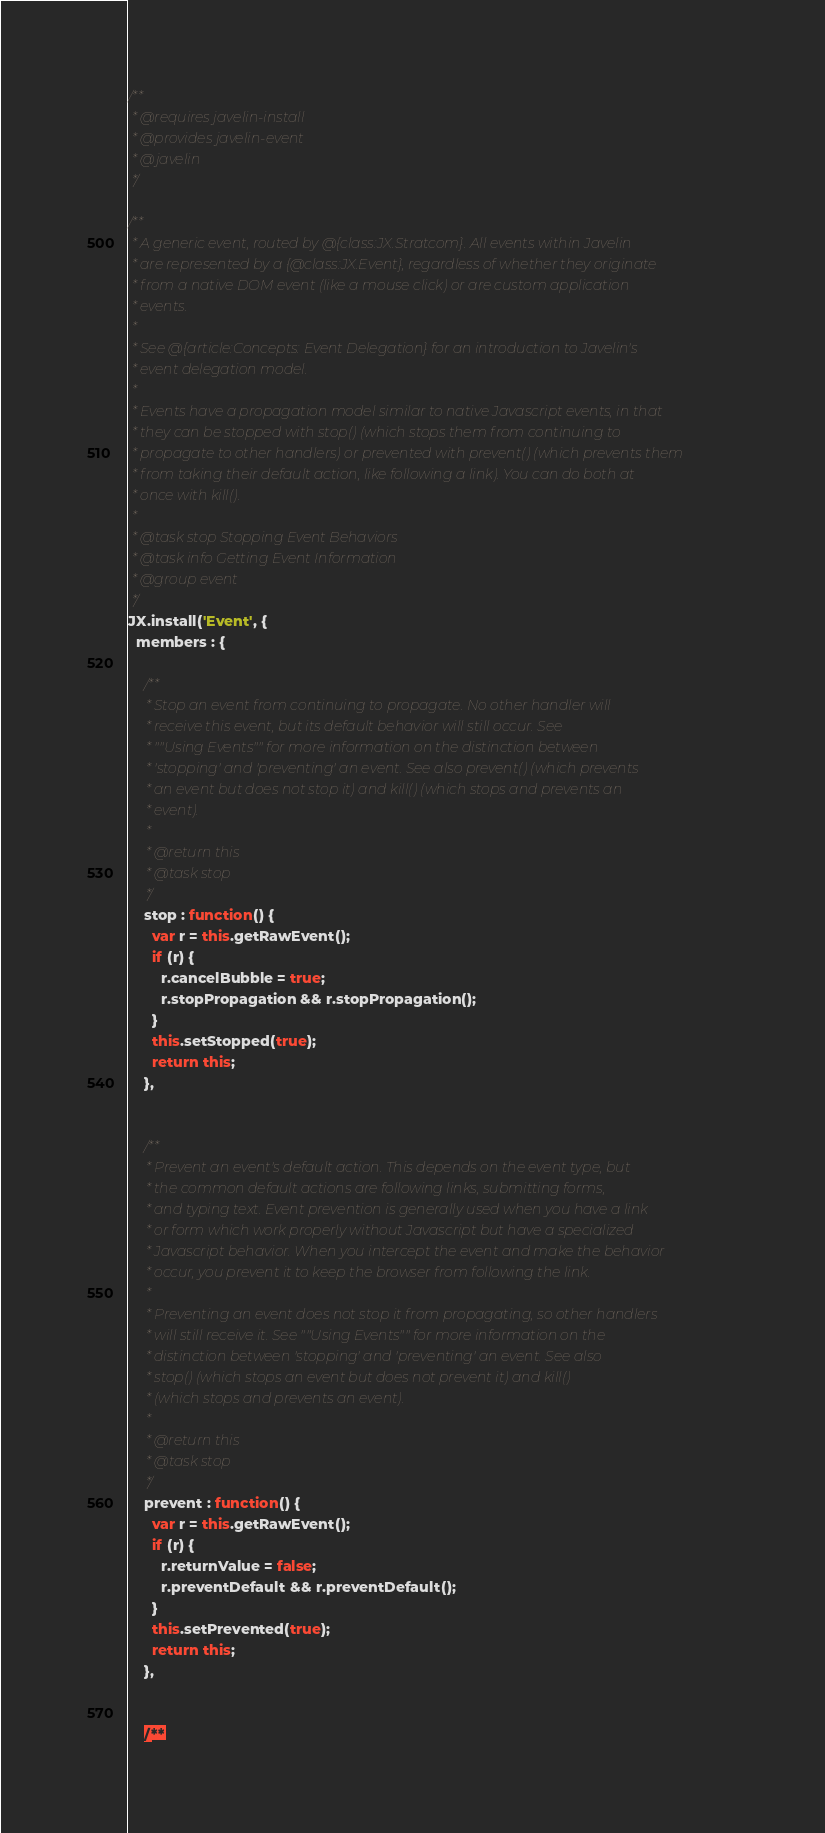<code> <loc_0><loc_0><loc_500><loc_500><_JavaScript_>/**
 * @requires javelin-install
 * @provides javelin-event
 * @javelin
 */

/**
 * A generic event, routed by @{class:JX.Stratcom}. All events within Javelin
 * are represented by a {@class:JX.Event}, regardless of whether they originate
 * from a native DOM event (like a mouse click) or are custom application
 * events.
 *
 * See @{article:Concepts: Event Delegation} for an introduction to Javelin's
 * event delegation model.
 *
 * Events have a propagation model similar to native Javascript events, in that
 * they can be stopped with stop() (which stops them from continuing to
 * propagate to other handlers) or prevented with prevent() (which prevents them
 * from taking their default action, like following a link). You can do both at
 * once with kill().
 *
 * @task stop Stopping Event Behaviors
 * @task info Getting Event Information
 * @group event
 */
JX.install('Event', {
  members : {

    /**
     * Stop an event from continuing to propagate. No other handler will
     * receive this event, but its default behavior will still occur. See
     * ""Using Events"" for more information on the distinction between
     * 'stopping' and 'preventing' an event. See also prevent() (which prevents
     * an event but does not stop it) and kill() (which stops and prevents an
     * event).
     *
     * @return this
     * @task stop
     */
    stop : function() {
      var r = this.getRawEvent();
      if (r) {
        r.cancelBubble = true;
        r.stopPropagation && r.stopPropagation();
      }
      this.setStopped(true);
      return this;
    },


    /**
     * Prevent an event's default action. This depends on the event type, but
     * the common default actions are following links, submitting forms,
     * and typing text. Event prevention is generally used when you have a link
     * or form which work properly without Javascript but have a specialized
     * Javascript behavior. When you intercept the event and make the behavior
     * occur, you prevent it to keep the browser from following the link.
     *
     * Preventing an event does not stop it from propagating, so other handlers
     * will still receive it. See ""Using Events"" for more information on the
     * distinction between 'stopping' and 'preventing' an event. See also
     * stop() (which stops an event but does not prevent it) and kill()
     * (which stops and prevents an event).
     *
     * @return this
     * @task stop
     */
    prevent : function() {
      var r = this.getRawEvent();
      if (r) {
        r.returnValue = false;
        r.preventDefault && r.preventDefault();
      }
      this.setPrevented(true);
      return this;
    },


    /**</code> 